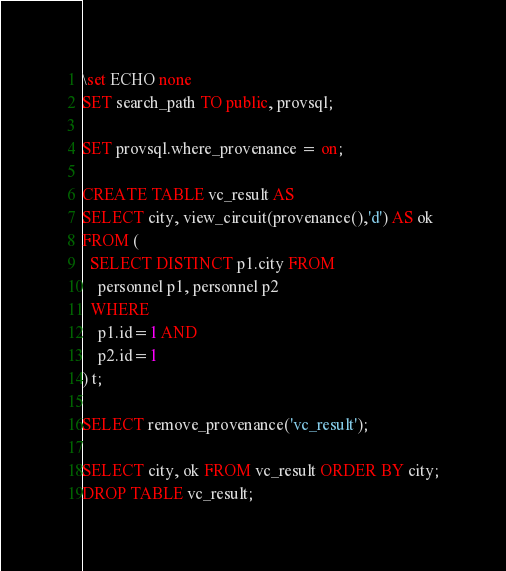Convert code to text. <code><loc_0><loc_0><loc_500><loc_500><_SQL_>\set ECHO none
SET search_path TO public, provsql;

SET provsql.where_provenance = on;

CREATE TABLE vc_result AS
SELECT city, view_circuit(provenance(),'d') AS ok
FROM ( 
  SELECT DISTINCT p1.city FROM
    personnel p1, personnel p2
  WHERE
    p1.id=1 AND
    p2.id=1
) t;

SELECT remove_provenance('vc_result');

SELECT city, ok FROM vc_result ORDER BY city;
DROP TABLE vc_result;
</code> 